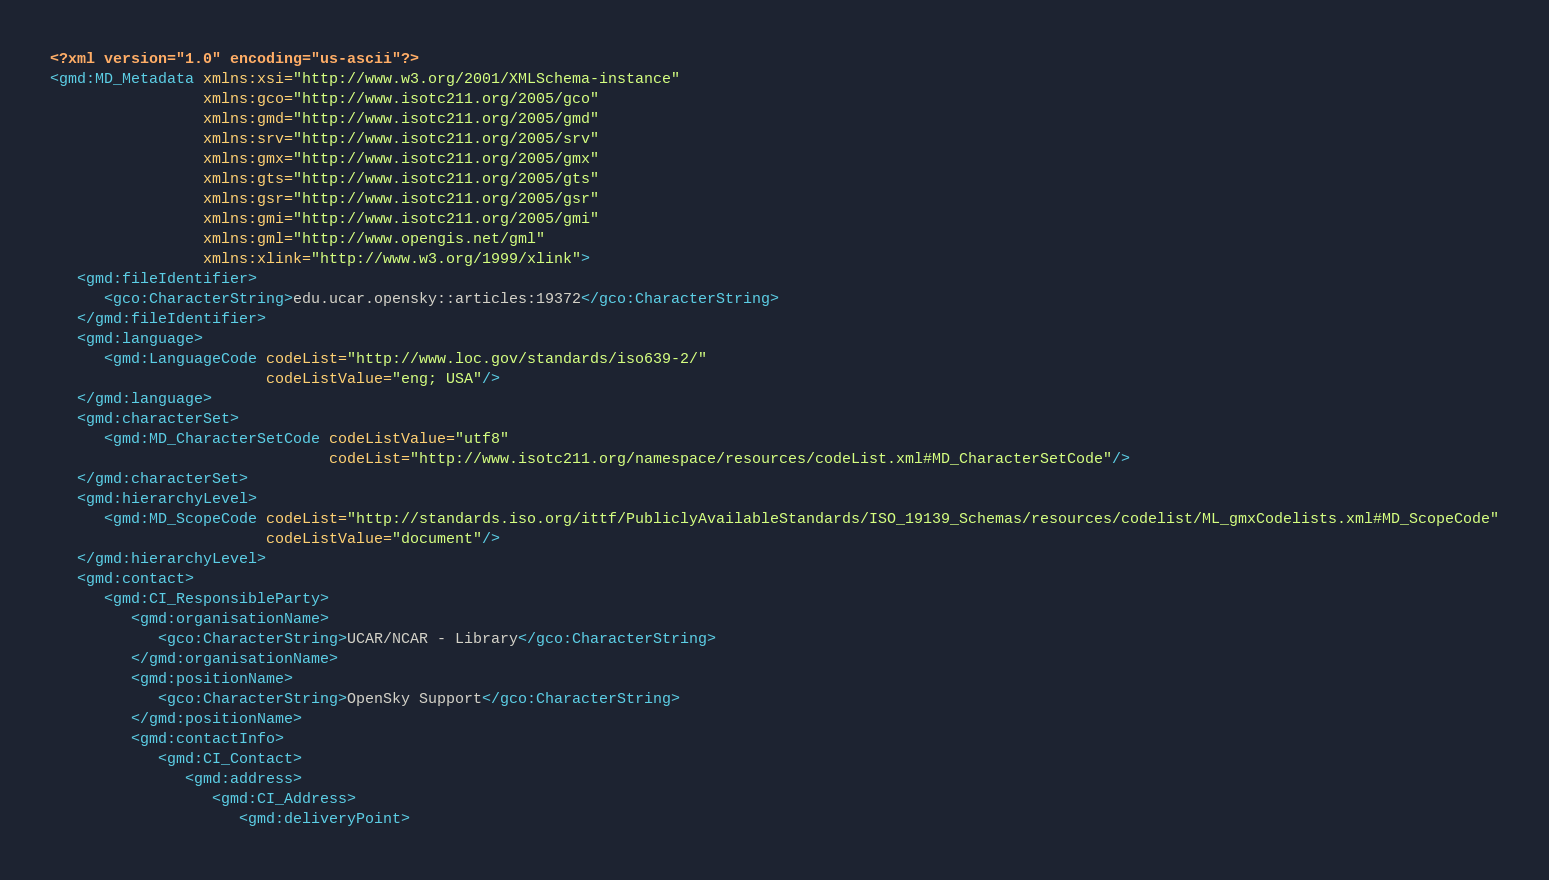<code> <loc_0><loc_0><loc_500><loc_500><_XML_><?xml version="1.0" encoding="us-ascii"?>
<gmd:MD_Metadata xmlns:xsi="http://www.w3.org/2001/XMLSchema-instance"
                 xmlns:gco="http://www.isotc211.org/2005/gco"
                 xmlns:gmd="http://www.isotc211.org/2005/gmd"
                 xmlns:srv="http://www.isotc211.org/2005/srv"
                 xmlns:gmx="http://www.isotc211.org/2005/gmx"
                 xmlns:gts="http://www.isotc211.org/2005/gts"
                 xmlns:gsr="http://www.isotc211.org/2005/gsr"
                 xmlns:gmi="http://www.isotc211.org/2005/gmi"
                 xmlns:gml="http://www.opengis.net/gml"
                 xmlns:xlink="http://www.w3.org/1999/xlink">
   <gmd:fileIdentifier>
      <gco:CharacterString>edu.ucar.opensky::articles:19372</gco:CharacterString>
   </gmd:fileIdentifier>
   <gmd:language>
      <gmd:LanguageCode codeList="http://www.loc.gov/standards/iso639-2/"
                        codeListValue="eng; USA"/>
   </gmd:language>
   <gmd:characterSet>
      <gmd:MD_CharacterSetCode codeListValue="utf8"
                               codeList="http://www.isotc211.org/namespace/resources/codeList.xml#MD_CharacterSetCode"/>
   </gmd:characterSet>
   <gmd:hierarchyLevel>
      <gmd:MD_ScopeCode codeList="http://standards.iso.org/ittf/PubliclyAvailableStandards/ISO_19139_Schemas/resources/codelist/ML_gmxCodelists.xml#MD_ScopeCode"
                        codeListValue="document"/>
   </gmd:hierarchyLevel>
   <gmd:contact>
      <gmd:CI_ResponsibleParty>
         <gmd:organisationName>
            <gco:CharacterString>UCAR/NCAR - Library</gco:CharacterString>
         </gmd:organisationName>
         <gmd:positionName>
            <gco:CharacterString>OpenSky Support</gco:CharacterString>
         </gmd:positionName>
         <gmd:contactInfo>
            <gmd:CI_Contact>
               <gmd:address>
                  <gmd:CI_Address>
                     <gmd:deliveryPoint></code> 